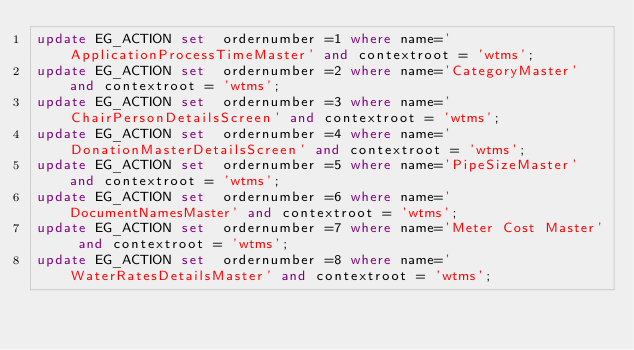<code> <loc_0><loc_0><loc_500><loc_500><_SQL_>update EG_ACTION set  ordernumber =1 where name='ApplicationProcessTimeMaster' and contextroot = 'wtms';
update EG_ACTION set  ordernumber =2 where name='CategoryMaster' and contextroot = 'wtms';
update EG_ACTION set  ordernumber =3 where name='ChairPersonDetailsScreen' and contextroot = 'wtms';
update EG_ACTION set  ordernumber =4 where name='DonationMasterDetailsScreen' and contextroot = 'wtms';
update EG_ACTION set  ordernumber =5 where name='PipeSizeMaster' and contextroot = 'wtms';
update EG_ACTION set  ordernumber =6 where name='DocumentNamesMaster' and contextroot = 'wtms';
update EG_ACTION set  ordernumber =7 where name='Meter Cost Master' and contextroot = 'wtms';
update EG_ACTION set  ordernumber =8 where name='WaterRatesDetailsMaster' and contextroot = 'wtms';</code> 